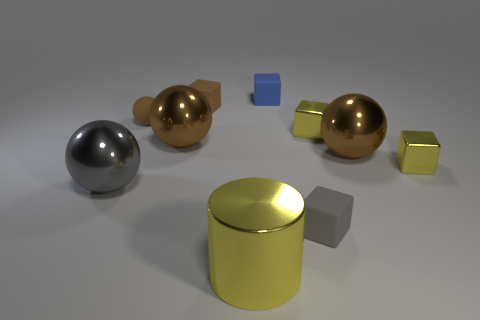How many brown balls must be subtracted to get 1 brown balls? 2 Subtract all cyan cylinders. How many brown spheres are left? 3 Subtract all blue cubes. How many cubes are left? 4 Subtract all purple blocks. Subtract all yellow cylinders. How many blocks are left? 5 Subtract all cylinders. How many objects are left? 9 Add 4 yellow cylinders. How many yellow cylinders exist? 5 Subtract 1 blue blocks. How many objects are left? 9 Subtract all big blue shiny spheres. Subtract all large metallic things. How many objects are left? 6 Add 7 blue matte blocks. How many blue matte blocks are left? 8 